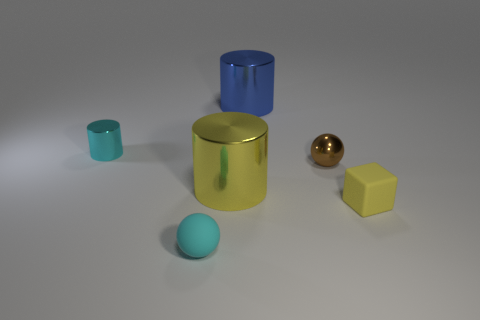Does the large thing that is to the right of the big yellow shiny thing have the same material as the block?
Your answer should be compact. No. There is a matte thing that is the same size as the matte block; what is its shape?
Ensure brevity in your answer.  Sphere. How many large cylinders are the same color as the tiny block?
Your response must be concise. 1. Are there fewer tiny matte objects to the right of the brown sphere than cylinders behind the rubber sphere?
Your answer should be compact. Yes. There is a small brown metal sphere; are there any big yellow metallic objects right of it?
Offer a terse response. No. Is there a yellow shiny thing that is right of the rubber thing left of the blue shiny cylinder behind the brown metallic thing?
Keep it short and to the point. Yes. Is the shape of the small rubber thing left of the tiny brown metallic thing the same as  the tiny brown thing?
Make the answer very short. Yes. There is a sphere that is made of the same material as the blue cylinder; what is its color?
Make the answer very short. Brown. How many blue objects have the same material as the tiny cyan cylinder?
Offer a very short reply. 1. What is the color of the cylinder that is left of the small ball in front of the brown metal ball in front of the blue thing?
Keep it short and to the point. Cyan. 